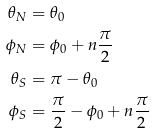Convert formula to latex. <formula><loc_0><loc_0><loc_500><loc_500>\theta _ { N } & = \theta _ { 0 } \\ \phi _ { N } & = \phi _ { 0 } + n \frac { \pi } { 2 } \\ \theta _ { S } & = \pi - \theta _ { 0 } \\ \phi _ { S } & = \frac { \pi } { 2 } - \phi _ { 0 } + n \frac { \pi } { 2 } \\</formula> 